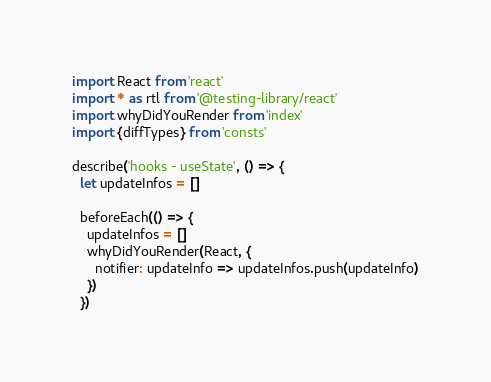Convert code to text. <code><loc_0><loc_0><loc_500><loc_500><_JavaScript_>import React from 'react'
import * as rtl from '@testing-library/react'
import whyDidYouRender from 'index'
import {diffTypes} from 'consts'

describe('hooks - useState', () => {
  let updateInfos = []

  beforeEach(() => {
    updateInfos = []
    whyDidYouRender(React, {
      notifier: updateInfo => updateInfos.push(updateInfo)
    })
  })
</code> 